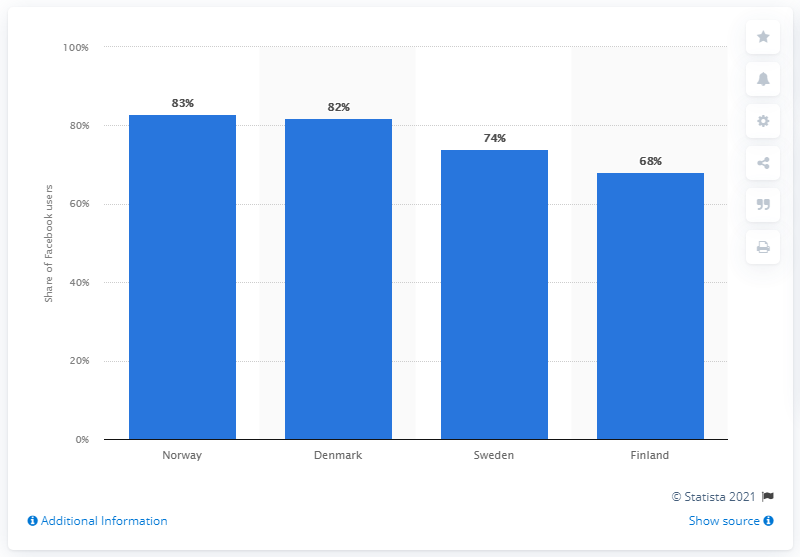Indicate a few pertinent items in this graphic. Finland has the highest percentage of daily Facebook users among all countries, according to recent data. 